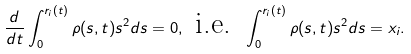Convert formula to latex. <formula><loc_0><loc_0><loc_500><loc_500>\frac { d } { d t } \int _ { 0 } ^ { r _ { i } ( t ) } \rho ( s , t ) s ^ { 2 } d s = 0 , \text { i.e. } \int _ { 0 } ^ { r _ { i } ( t ) } \rho ( s , t ) s ^ { 2 } d s = x _ { i } .</formula> 